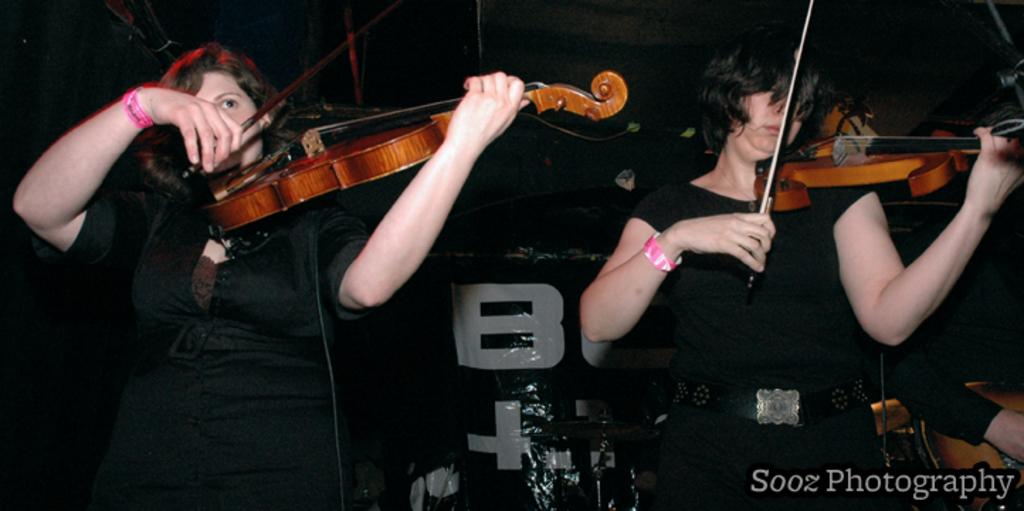What are the people in the image doing? The people in the image are playing musical instruments. What are the people wearing while playing the musical instruments? The people are wearing colorful black shirts. Can you see any jellyfish floating in the air in the image? There are no jellyfish present in the image. How many eyes does the person playing the musical instrument have in the image? The number of eyes a person has cannot be determined from the image alone. 